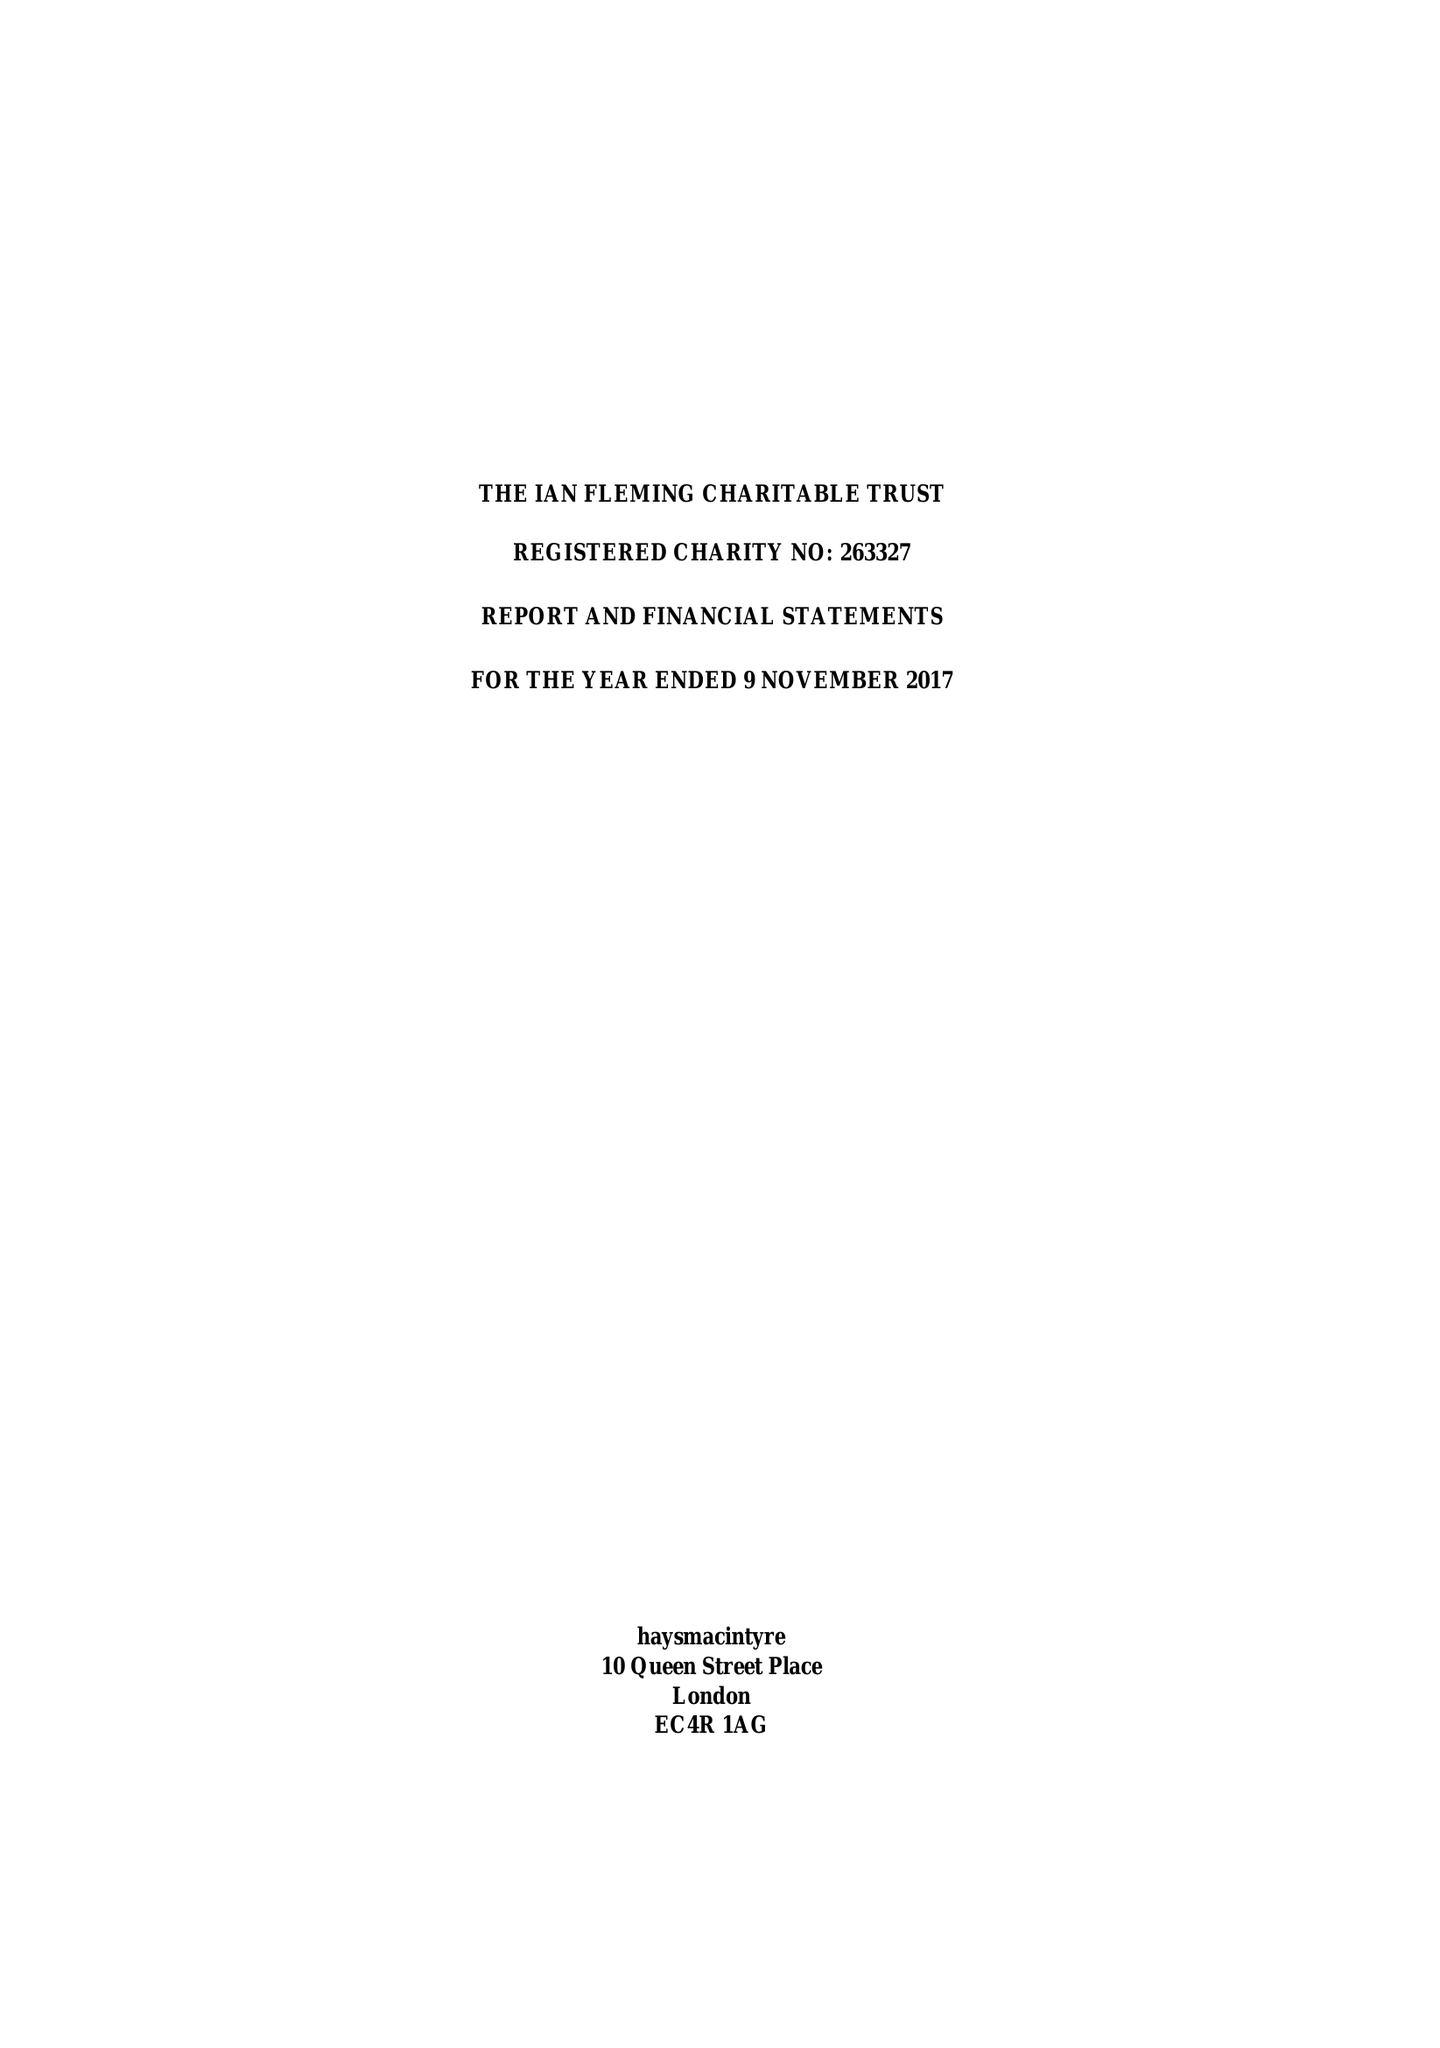What is the value for the address__street_line?
Answer the question using a single word or phrase. 10 QUEEN STREET PLACE 